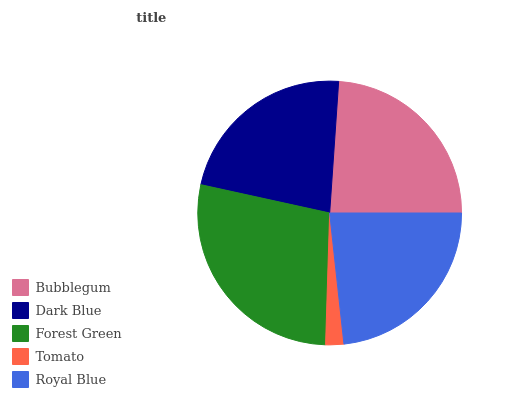Is Tomato the minimum?
Answer yes or no. Yes. Is Forest Green the maximum?
Answer yes or no. Yes. Is Dark Blue the minimum?
Answer yes or no. No. Is Dark Blue the maximum?
Answer yes or no. No. Is Bubblegum greater than Dark Blue?
Answer yes or no. Yes. Is Dark Blue less than Bubblegum?
Answer yes or no. Yes. Is Dark Blue greater than Bubblegum?
Answer yes or no. No. Is Bubblegum less than Dark Blue?
Answer yes or no. No. Is Royal Blue the high median?
Answer yes or no. Yes. Is Royal Blue the low median?
Answer yes or no. Yes. Is Forest Green the high median?
Answer yes or no. No. Is Dark Blue the low median?
Answer yes or no. No. 